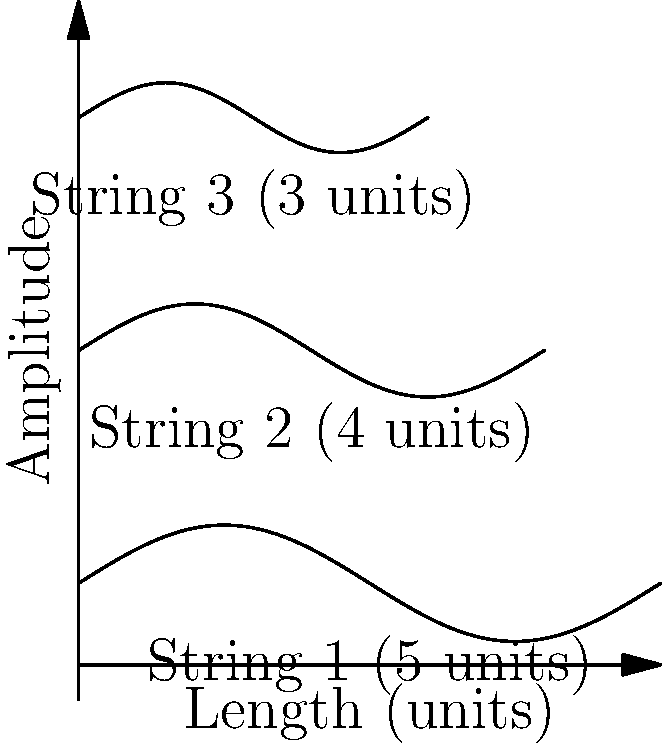As an aspiring country singer, you're learning about the physics of guitar strings to improve your performances. The image shows standing waves on three guitar strings of different lengths, all vibrating with the same number of nodes. If the fundamental frequency of String 1 is 110 Hz (A2 note), what would be the fundamental frequency of String 3? Let's approach this step-by-step:

1) The fundamental frequency (f) of a vibrating string is inversely proportional to its length (L). This relationship can be expressed as:

   $f \propto \frac{1}{L}$

2) We can write this as an equation:

   $f_1L_1 = f_3L_3$

   Where $f_1$ and $L_1$ are the frequency and length of String 1, and $f_3$ and $L_3$ are for String 3.

3) We're given:
   - $f_1 = 110$ Hz
   - $L_1 = 5$ units
   - $L_3 = 3$ units

4) Let's substitute these values into our equation:

   $110 \cdot 5 = f_3 \cdot 3$

5) Now we can solve for $f_3$:

   $f_3 = \frac{110 \cdot 5}{3} = \frac{550}{3} \approx 183.33$ Hz

6) Rounding to the nearest whole number:

   $f_3 \approx 183$ Hz

This frequency is close to the F#3 note (185 Hz) on a guitar, which could be useful knowledge for tuning and composing country duets!
Answer: 183 Hz 